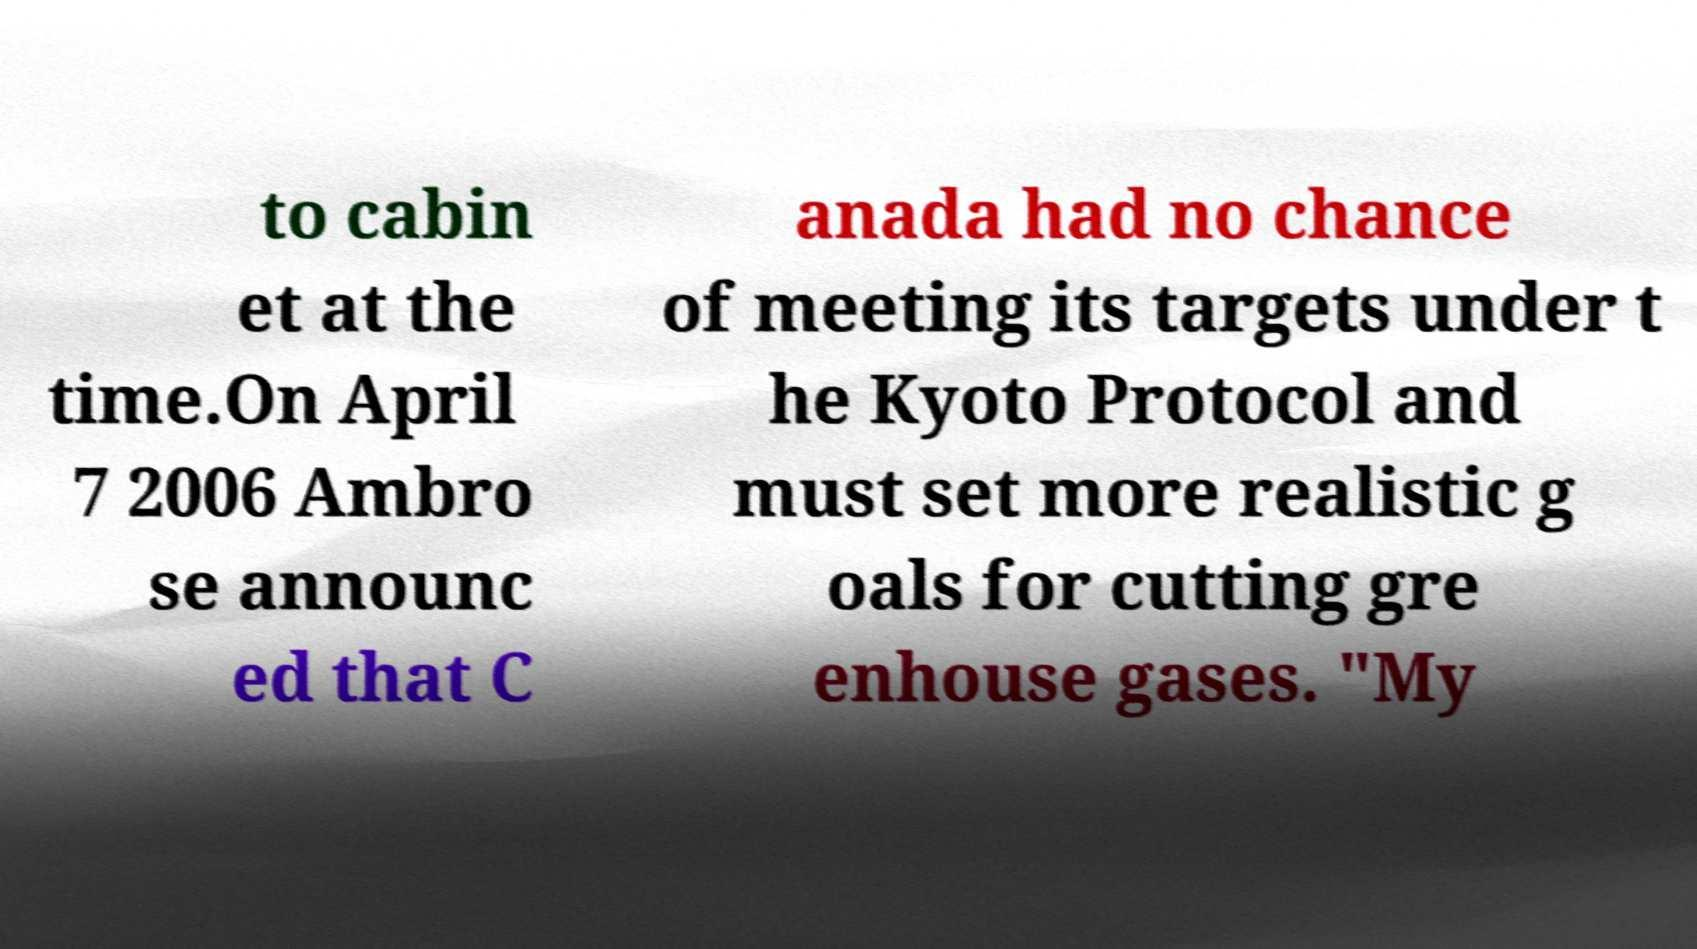Could you assist in decoding the text presented in this image and type it out clearly? to cabin et at the time.On April 7 2006 Ambro se announc ed that C anada had no chance of meeting its targets under t he Kyoto Protocol and must set more realistic g oals for cutting gre enhouse gases. "My 